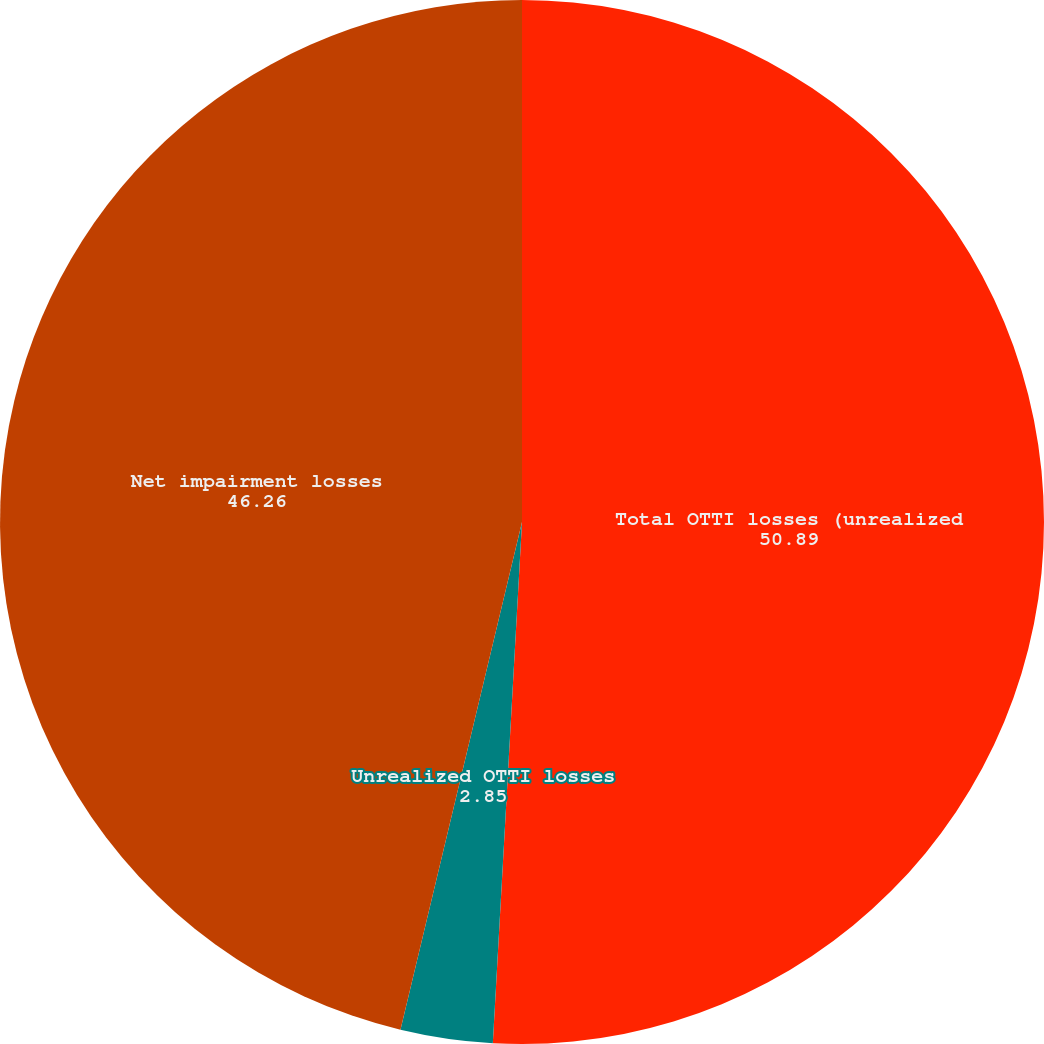<chart> <loc_0><loc_0><loc_500><loc_500><pie_chart><fcel>Total OTTI losses (unrealized<fcel>Unrealized OTTI losses<fcel>Net impairment losses<nl><fcel>50.89%<fcel>2.85%<fcel>46.26%<nl></chart> 